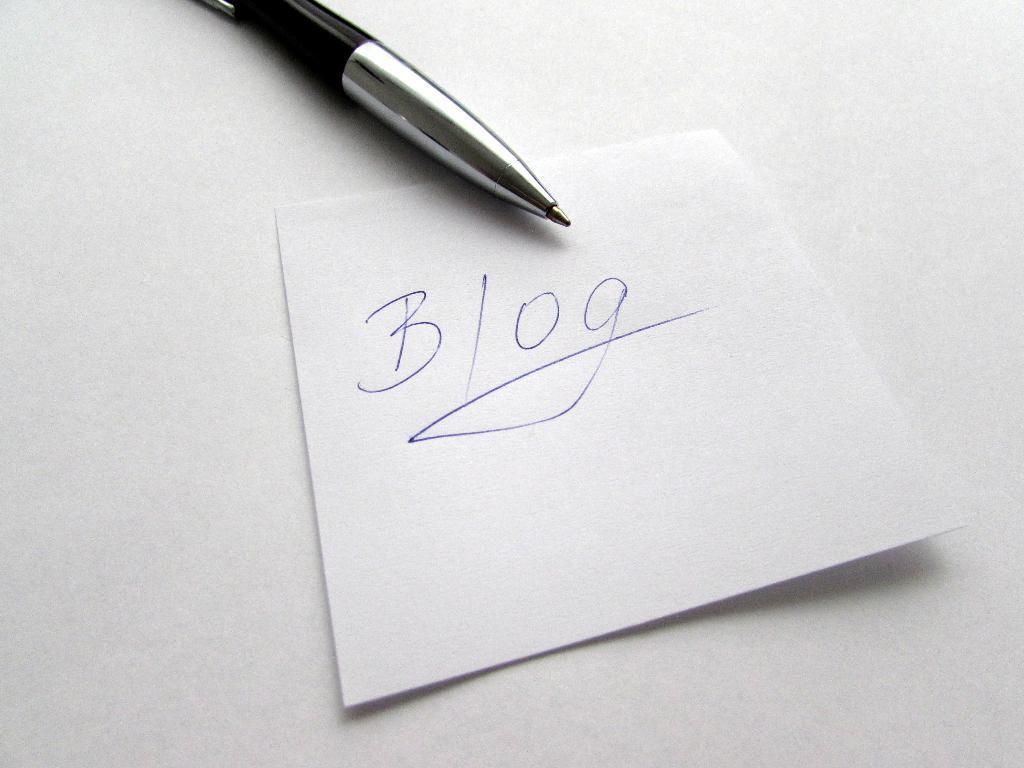Can you describe this image briefly? In this image I can see the white color paper and something is written on it with blue color. I can see a pen on the white surface. 